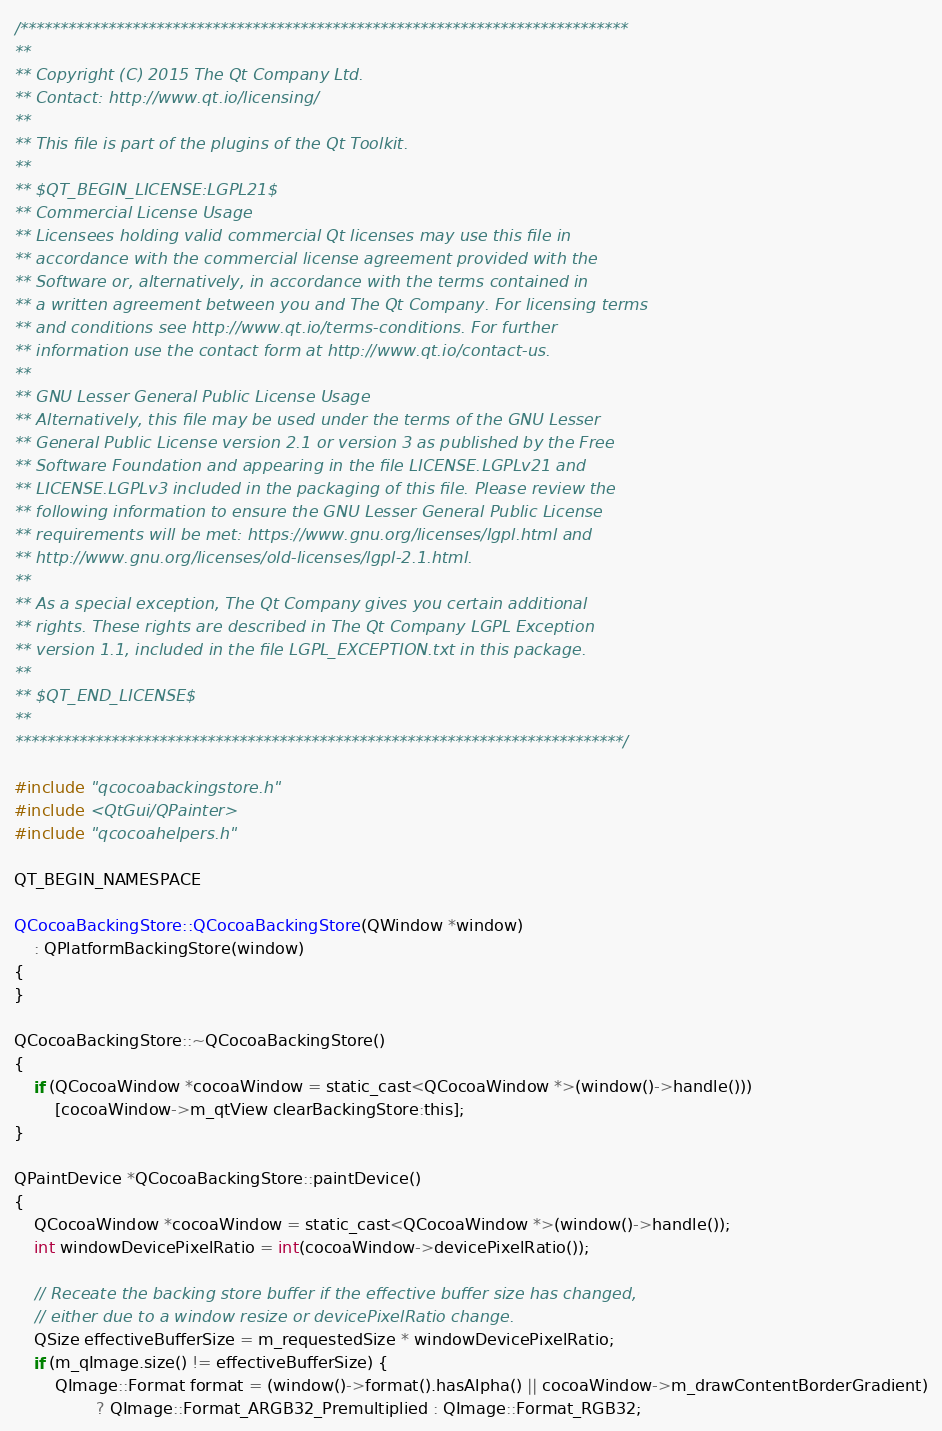<code> <loc_0><loc_0><loc_500><loc_500><_ObjectiveC_>/****************************************************************************
**
** Copyright (C) 2015 The Qt Company Ltd.
** Contact: http://www.qt.io/licensing/
**
** This file is part of the plugins of the Qt Toolkit.
**
** $QT_BEGIN_LICENSE:LGPL21$
** Commercial License Usage
** Licensees holding valid commercial Qt licenses may use this file in
** accordance with the commercial license agreement provided with the
** Software or, alternatively, in accordance with the terms contained in
** a written agreement between you and The Qt Company. For licensing terms
** and conditions see http://www.qt.io/terms-conditions. For further
** information use the contact form at http://www.qt.io/contact-us.
**
** GNU Lesser General Public License Usage
** Alternatively, this file may be used under the terms of the GNU Lesser
** General Public License version 2.1 or version 3 as published by the Free
** Software Foundation and appearing in the file LICENSE.LGPLv21 and
** LICENSE.LGPLv3 included in the packaging of this file. Please review the
** following information to ensure the GNU Lesser General Public License
** requirements will be met: https://www.gnu.org/licenses/lgpl.html and
** http://www.gnu.org/licenses/old-licenses/lgpl-2.1.html.
**
** As a special exception, The Qt Company gives you certain additional
** rights. These rights are described in The Qt Company LGPL Exception
** version 1.1, included in the file LGPL_EXCEPTION.txt in this package.
**
** $QT_END_LICENSE$
**
****************************************************************************/

#include "qcocoabackingstore.h"
#include <QtGui/QPainter>
#include "qcocoahelpers.h"

QT_BEGIN_NAMESPACE

QCocoaBackingStore::QCocoaBackingStore(QWindow *window)
    : QPlatformBackingStore(window)
{
}

QCocoaBackingStore::~QCocoaBackingStore()
{
    if (QCocoaWindow *cocoaWindow = static_cast<QCocoaWindow *>(window()->handle()))
        [cocoaWindow->m_qtView clearBackingStore:this];
}

QPaintDevice *QCocoaBackingStore::paintDevice()
{
    QCocoaWindow *cocoaWindow = static_cast<QCocoaWindow *>(window()->handle());
    int windowDevicePixelRatio = int(cocoaWindow->devicePixelRatio());

    // Receate the backing store buffer if the effective buffer size has changed,
    // either due to a window resize or devicePixelRatio change.
    QSize effectiveBufferSize = m_requestedSize * windowDevicePixelRatio;
    if (m_qImage.size() != effectiveBufferSize) {
        QImage::Format format = (window()->format().hasAlpha() || cocoaWindow->m_drawContentBorderGradient)
                ? QImage::Format_ARGB32_Premultiplied : QImage::Format_RGB32;</code> 